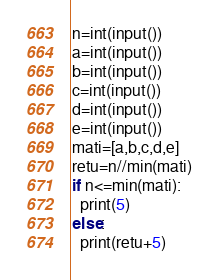<code> <loc_0><loc_0><loc_500><loc_500><_Python_>n=int(input())
a=int(input())
b=int(input())
c=int(input())
d=int(input())
e=int(input())
mati=[a,b,c,d,e]
retu=n//min(mati)
if n<=min(mati):
  print(5)
else:
  print(retu+5)</code> 